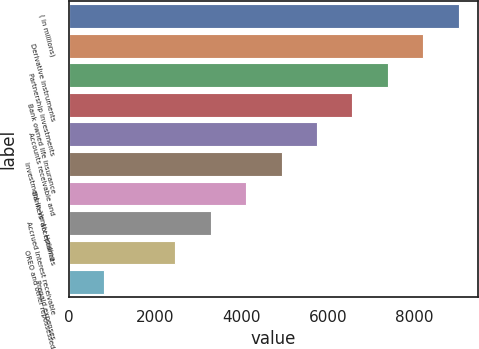Convert chart. <chart><loc_0><loc_0><loc_500><loc_500><bar_chart><fcel>( in millions)<fcel>Derivative instruments<fcel>Partnership investments<fcel>Bank owned life insurance<fcel>Accounts receivable and<fcel>Investment in Vantiv Holding<fcel>Bankers' acceptances<fcel>Accrued interest receivable<fcel>OREO and other repossessed<fcel>Prepaid expenses<nl><fcel>9023.4<fcel>8204<fcel>7384.6<fcel>6565.2<fcel>5745.8<fcel>4926.4<fcel>4107<fcel>3287.6<fcel>2468.2<fcel>829.4<nl></chart> 